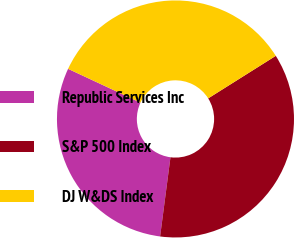<chart> <loc_0><loc_0><loc_500><loc_500><pie_chart><fcel>Republic Services Inc<fcel>S&P 500 Index<fcel>DJ W&DS Index<nl><fcel>29.88%<fcel>36.01%<fcel>34.11%<nl></chart> 